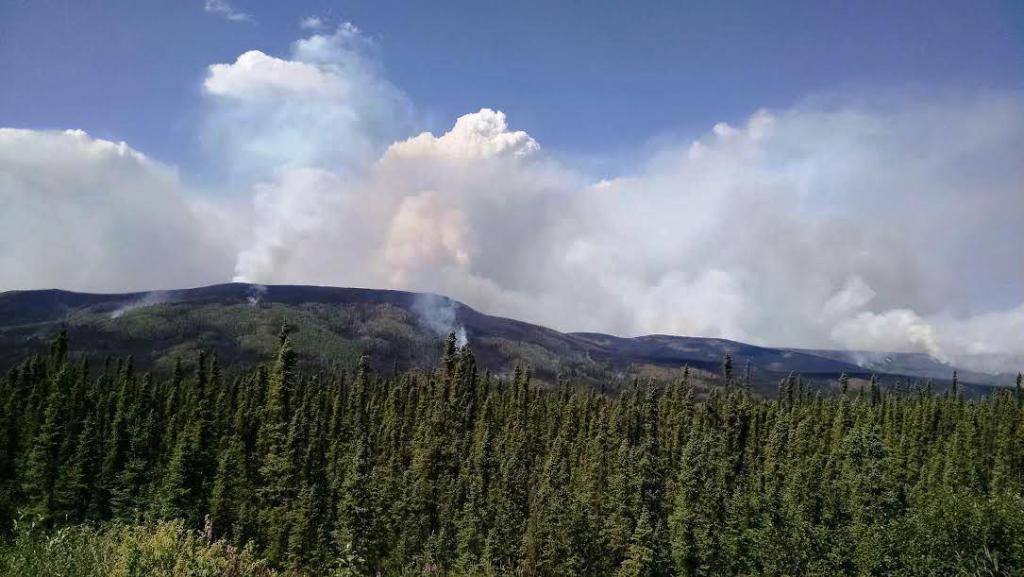What type of natural elements can be seen in the image? There are trees and hills visible in the image. What else can be observed in the image? There is smoke visible in the image. How would you describe the sky in the image? The sky is cloudy in the image. What type of authority figure can be seen sleeping in the image? There is no authority figure or anyone sleeping present in the image. What is the altitude of the low-flying aircraft in the image? There is no aircraft present in the image. 